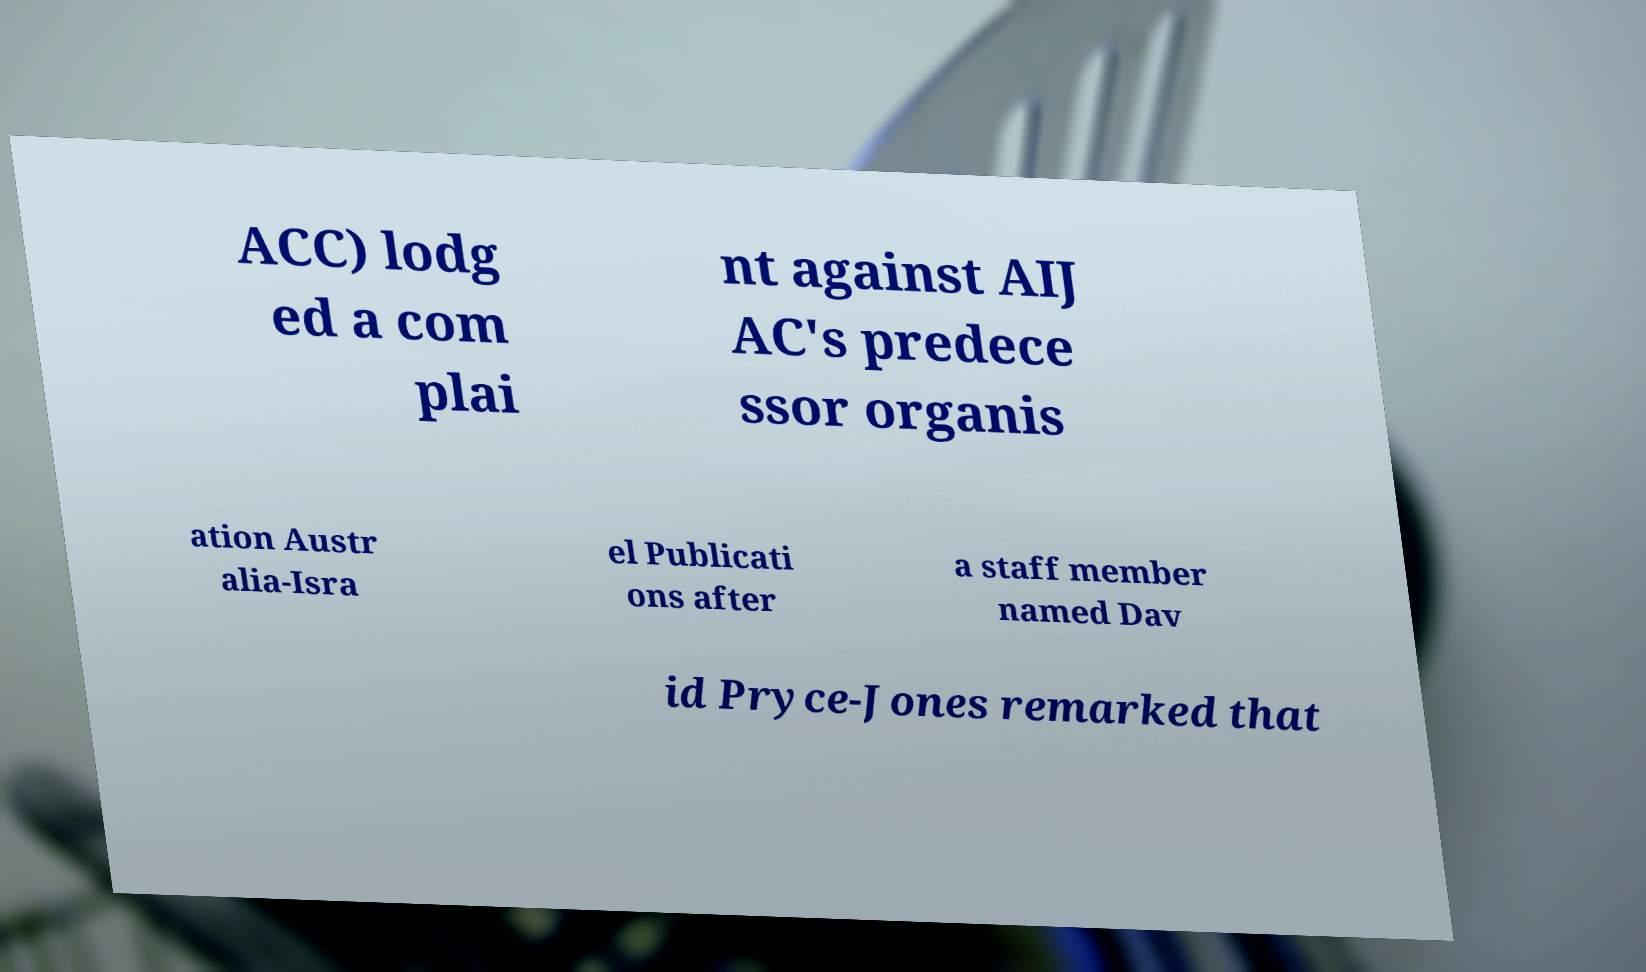Could you assist in decoding the text presented in this image and type it out clearly? ACC) lodg ed a com plai nt against AIJ AC's predece ssor organis ation Austr alia-Isra el Publicati ons after a staff member named Dav id Pryce-Jones remarked that 